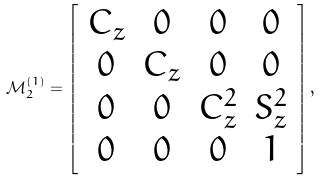Convert formula to latex. <formula><loc_0><loc_0><loc_500><loc_500>\mathcal { M } _ { 2 } ^ { ( 1 ) } = \left [ \begin{array} { c c c c } C _ { z } & 0 & 0 & 0 \\ 0 & C _ { z } & 0 & 0 \\ 0 & 0 & C _ { z } ^ { 2 } & S _ { z } ^ { 2 } \\ 0 & 0 & 0 & 1 \end{array} \right ] ,</formula> 